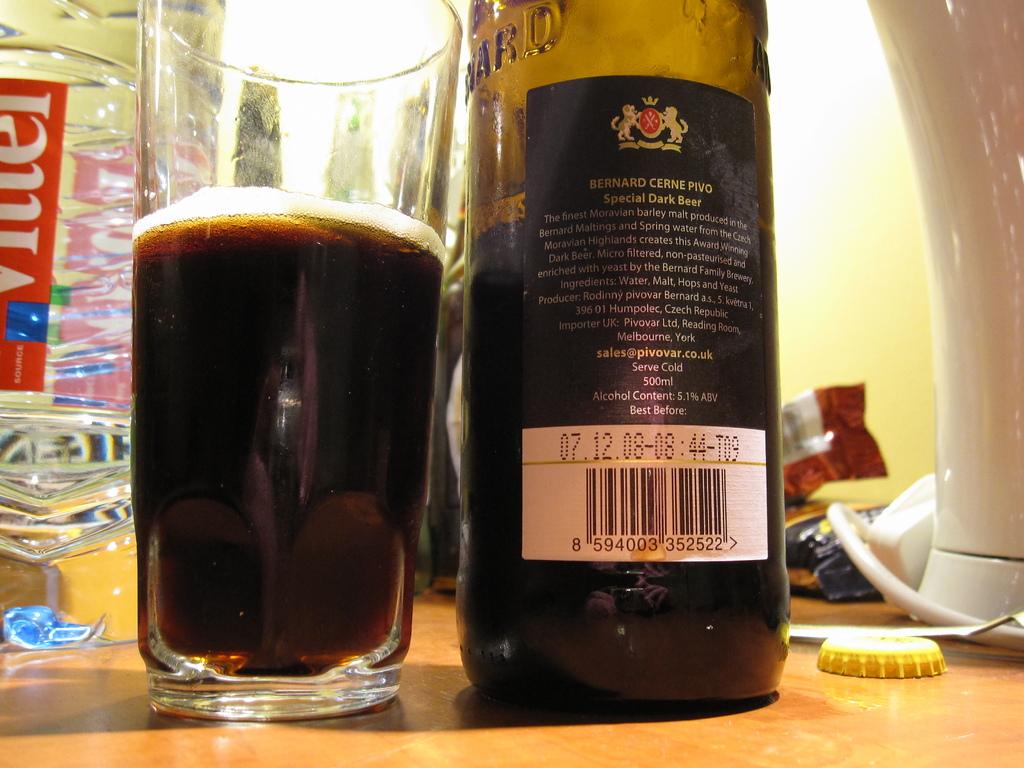What kind of beer is it?
Ensure brevity in your answer.  Special dark beer. 